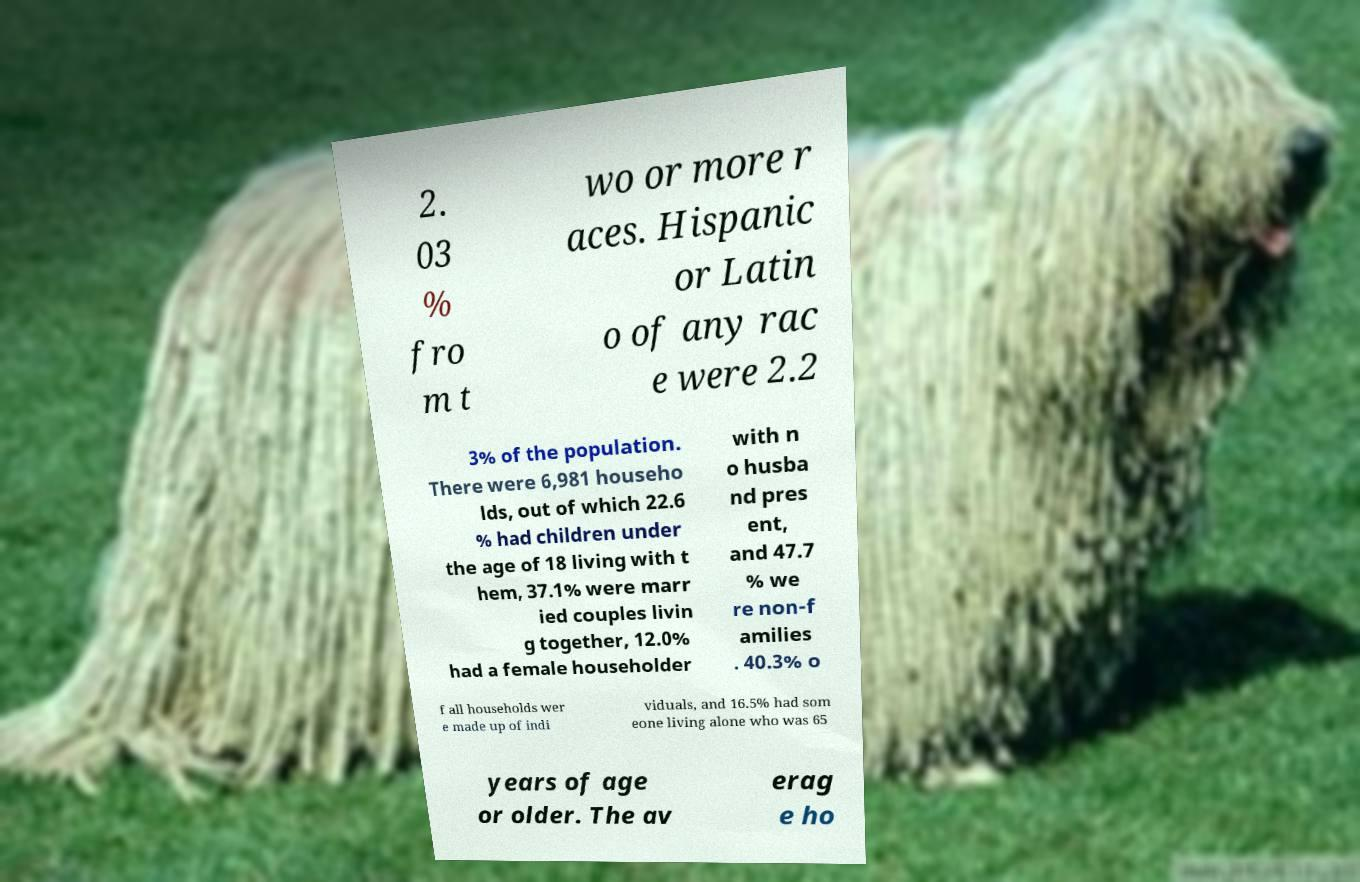Can you read and provide the text displayed in the image?This photo seems to have some interesting text. Can you extract and type it out for me? 2. 03 % fro m t wo or more r aces. Hispanic or Latin o of any rac e were 2.2 3% of the population. There were 6,981 househo lds, out of which 22.6 % had children under the age of 18 living with t hem, 37.1% were marr ied couples livin g together, 12.0% had a female householder with n o husba nd pres ent, and 47.7 % we re non-f amilies . 40.3% o f all households wer e made up of indi viduals, and 16.5% had som eone living alone who was 65 years of age or older. The av erag e ho 